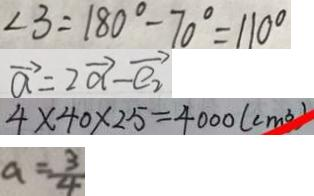<formula> <loc_0><loc_0><loc_500><loc_500>\angle 3 = 1 8 0 ^ { \circ } - 7 0 ^ { \circ } = 1 1 0 ^ { \circ } 
 \overrightarrow { a } = \overrightarrow { 2 a } - \overrightarrow { e _ { 2 } } 
 4 \times 4 0 \times 2 5 = 4 0 0 0 ( c m ^ { 3 } ) 
 a = \frac { 3 } { 4 }</formula> 